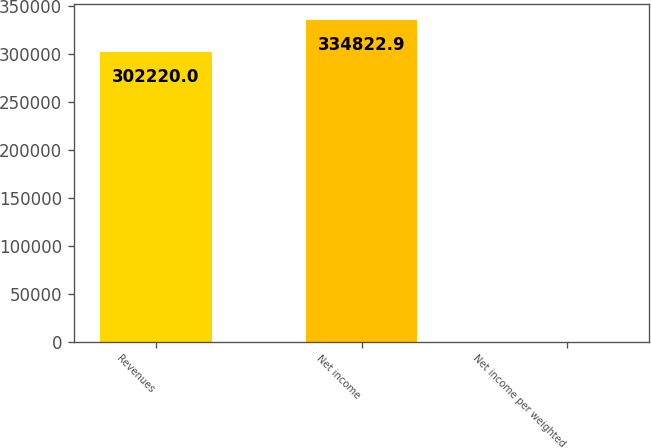Convert chart to OTSL. <chart><loc_0><loc_0><loc_500><loc_500><bar_chart><fcel>Revenues<fcel>Net income<fcel>Net income per weighted<nl><fcel>302220<fcel>334823<fcel>1.97<nl></chart> 